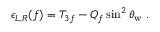<formula> <loc_0><loc_0><loc_500><loc_500>\epsilon _ { L , R } ( f ) = T _ { 3 f } - Q _ { f } \sin ^ { 2 } \theta _ { w } \, .</formula> 